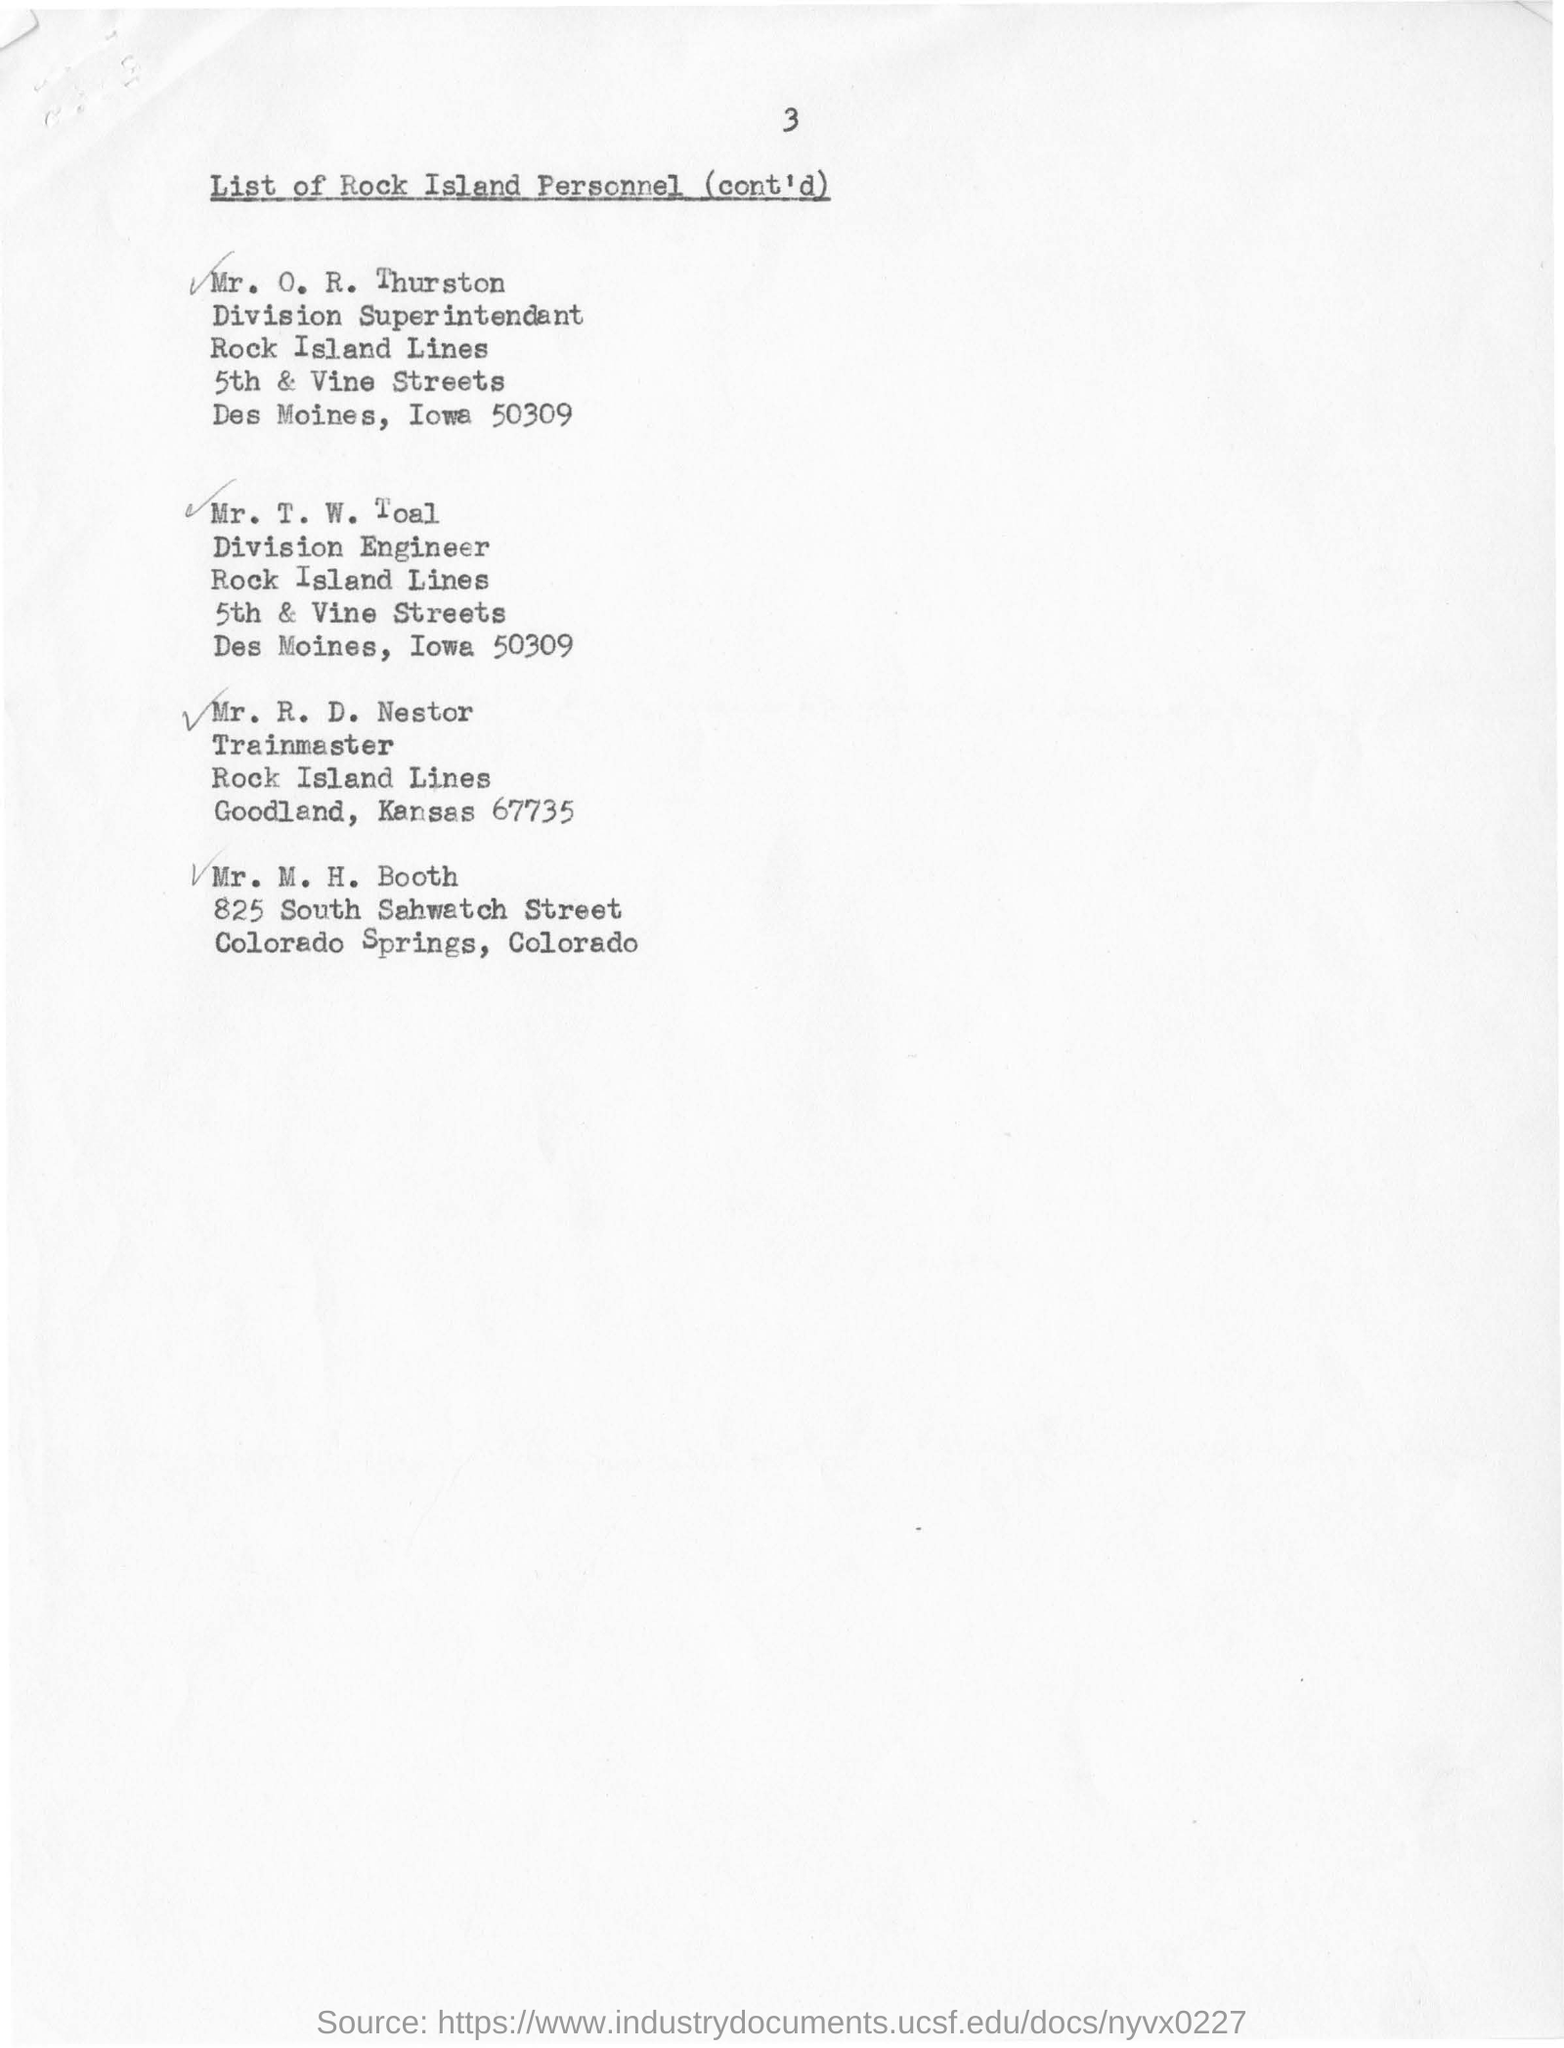Who is the division superintendant of rock island lines ?
Provide a succinct answer. Mr. O. R. Thurston. Who is the train master in rock island lines goodland,kansas 67735
Your answer should be compact. Mr. R. D. Nestor. Who is the division engineer in rock island lines ?
Your answer should be compact. Mr. T. W. Toal. 